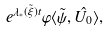Convert formula to latex. <formula><loc_0><loc_0><loc_500><loc_500>e ^ { \lambda _ { * } ( \tilde { \xi } ) t } \varphi \langle \tilde { \psi } , \hat { U _ { 0 } } \rangle ,</formula> 